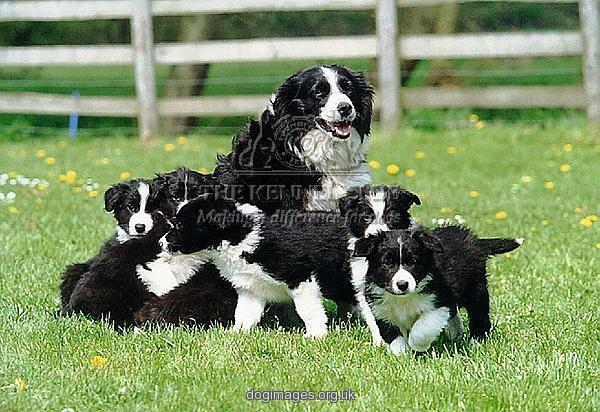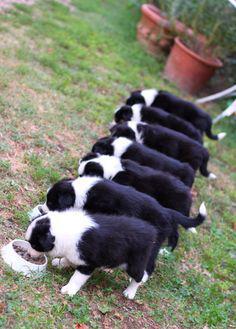The first image is the image on the left, the second image is the image on the right. Considering the images on both sides, is "There are at least seven dogs in the image on the right." valid? Answer yes or no. Yes. 